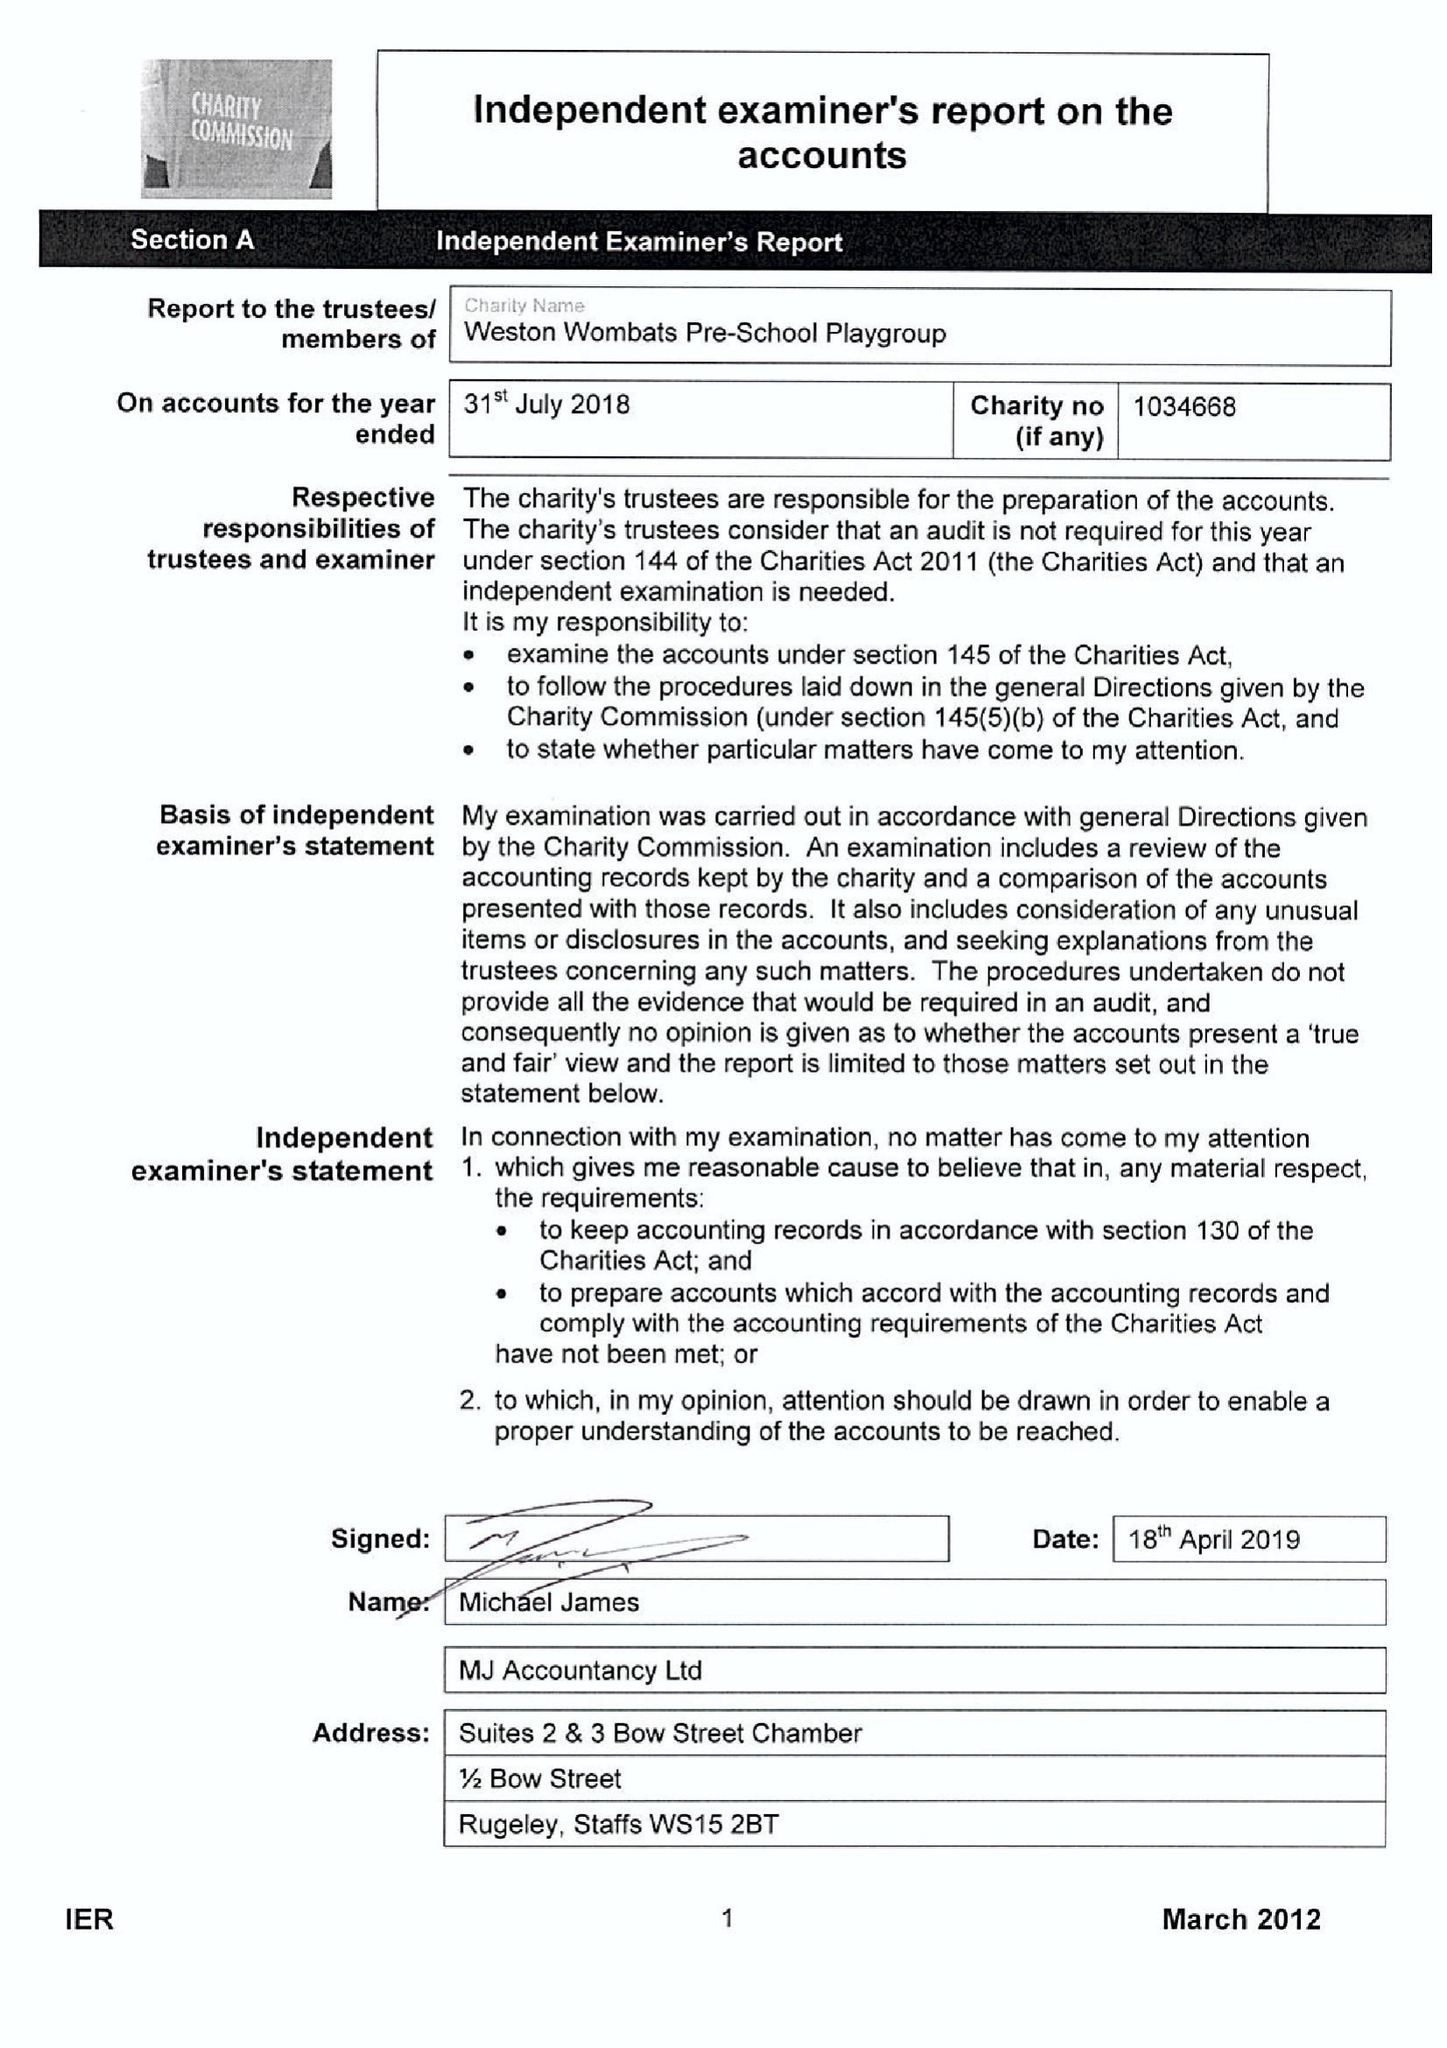What is the value for the charity_name?
Answer the question using a single word or phrase. Weston Wombats Pre-School Playgroup 